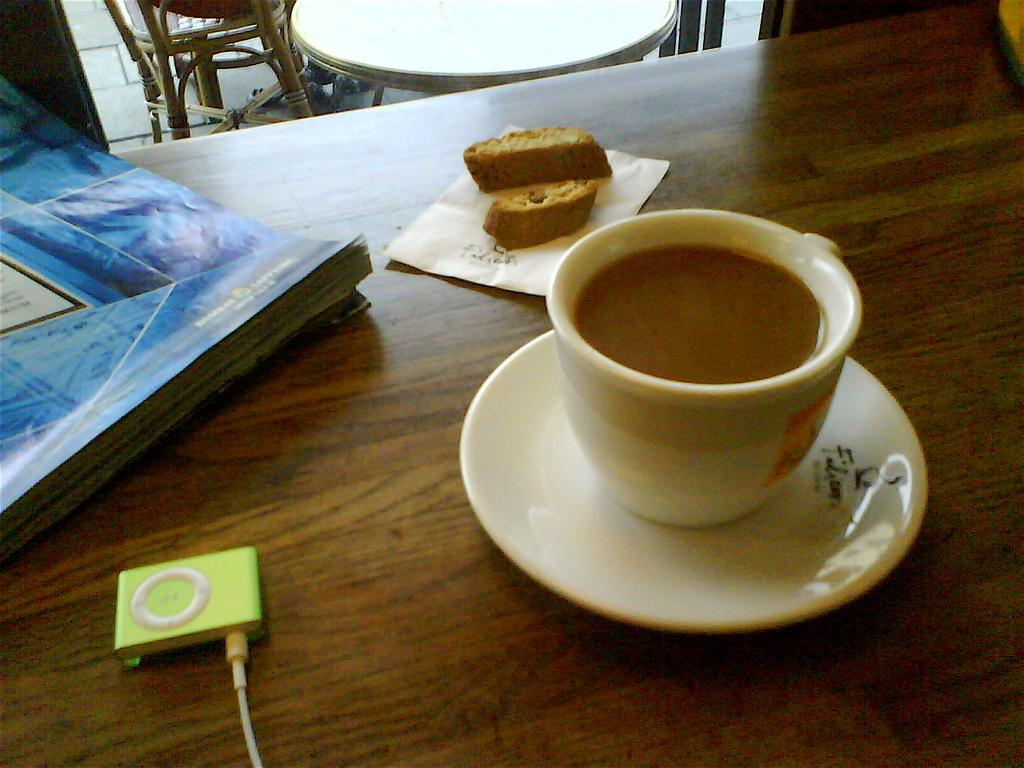What is the main object in the center of the image? There is a table in the center of the image. What items can be found on the table? On the table, there is a coffee cup, a saucer, bread, tissue paper, a book, and an iPod. What can be seen in the background of the image? In the background, there is another table and chairs. What type of slope can be seen in the image? There is no slope present in the image. What substance is the book made of in the image? The book is made of paper, but the specific substance cannot be determined from the image alone. 